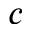<formula> <loc_0><loc_0><loc_500><loc_500>c</formula> 